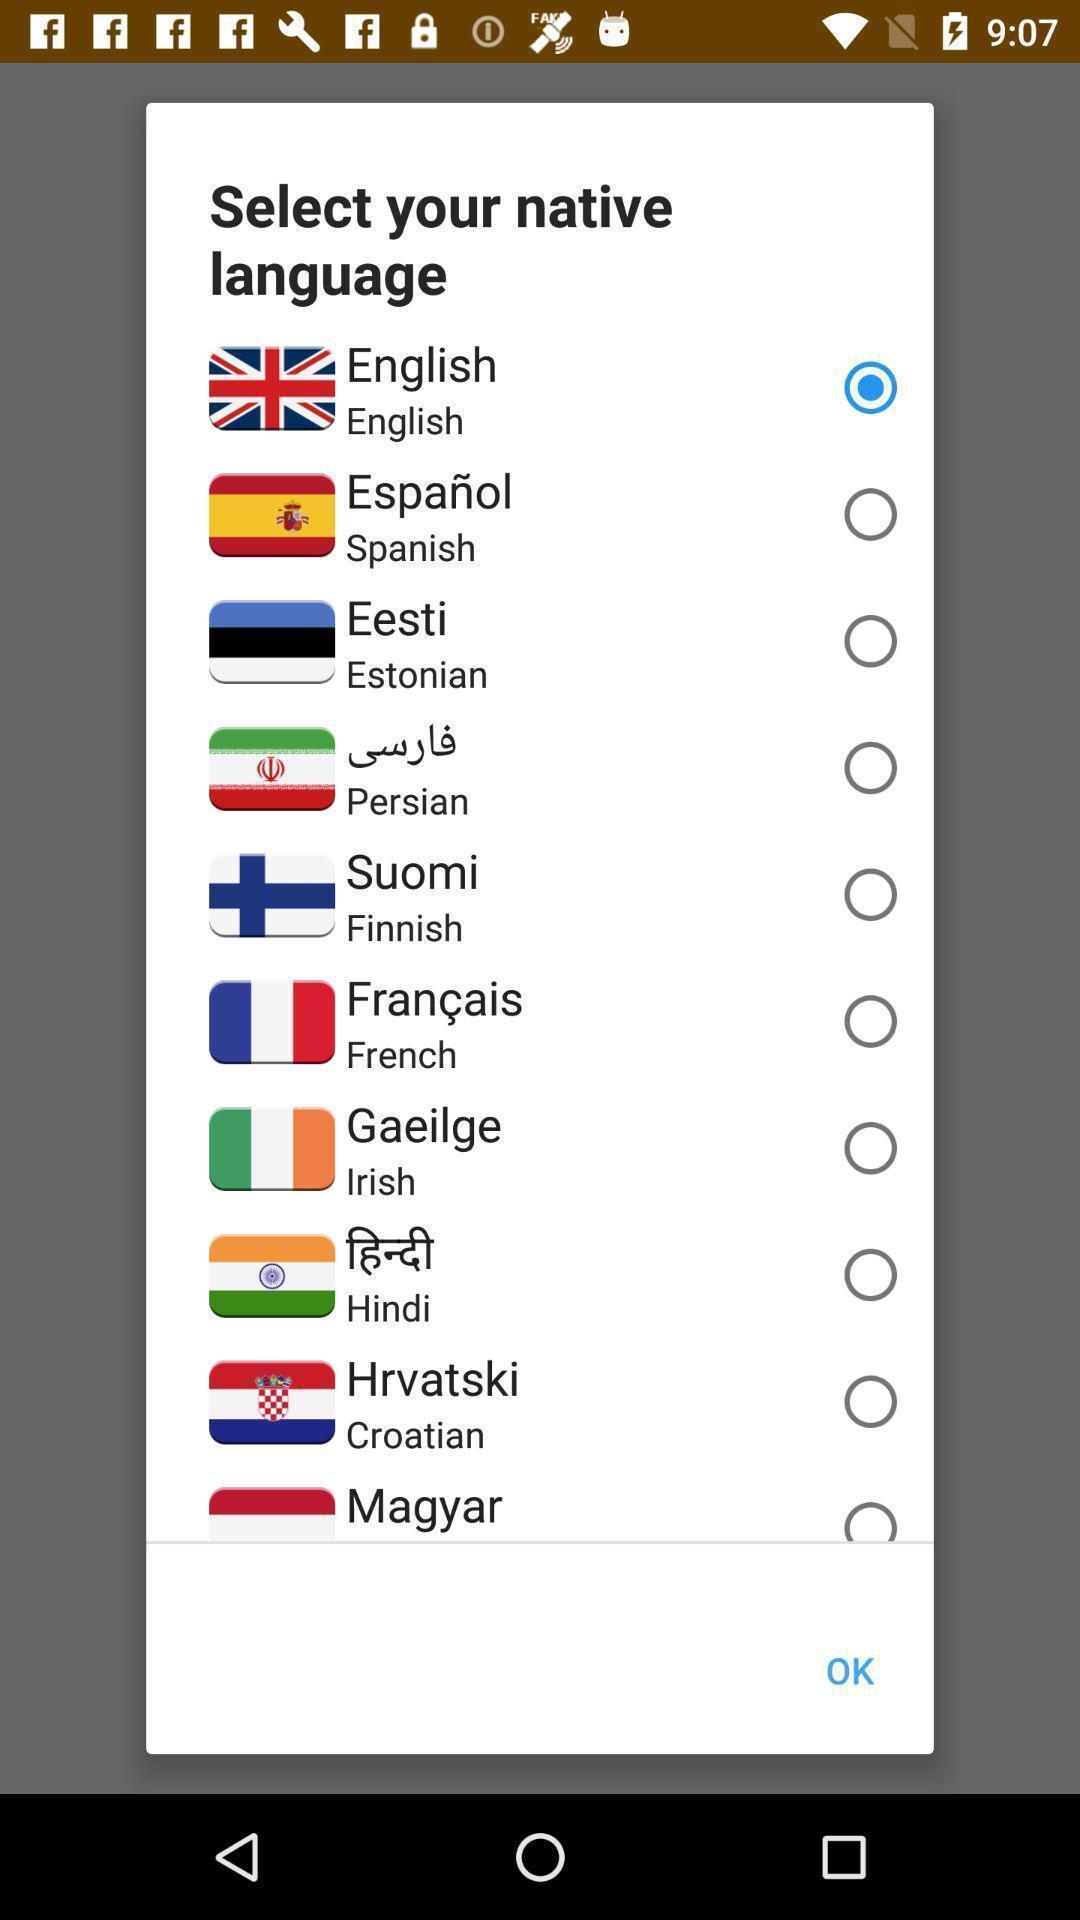Summarize the information in this screenshot. Pop-up shows to select native language. 